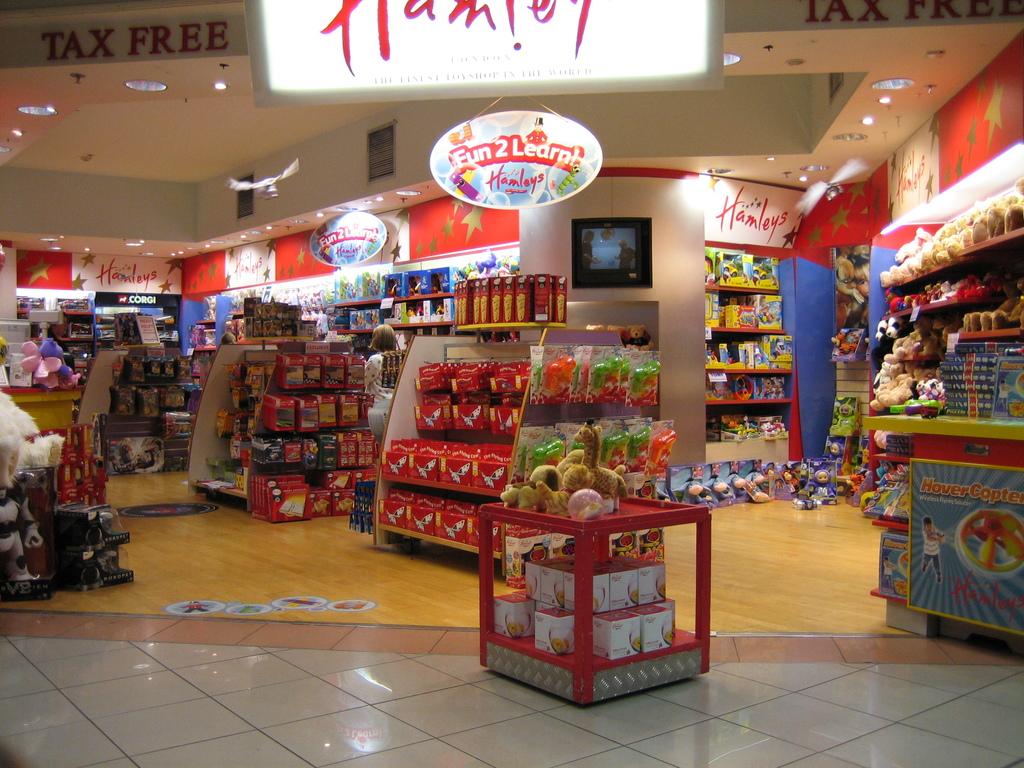What is the word on the display on the far right?
Your answer should be very brief. Hamleys. 